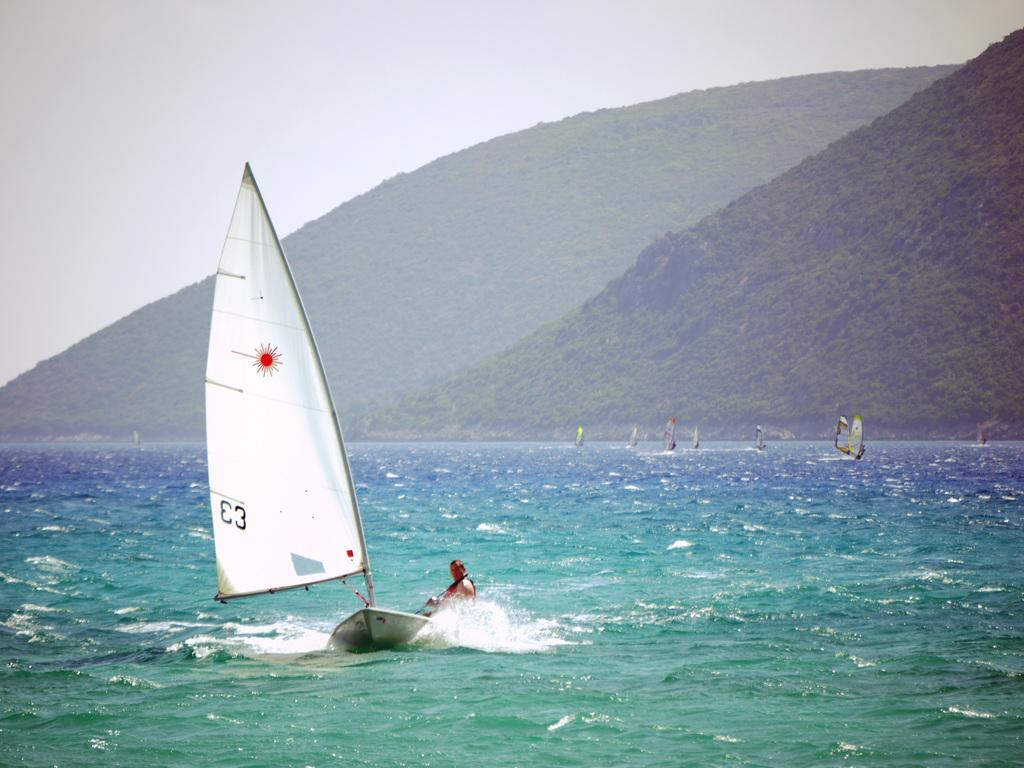What is located in the front of the image? There is water and boats in the front of the image. Can you describe the person in the image? There is a person in the front of the image. What can be seen in the background of the image? There are mountains, plants, and the sky visible in the background of the image. What type of powder is being used by the person in the image? There is no powder present in the image; it features water, boats, a person, mountains, plants, and the sky. How many pets are visible in the image? There are no pets present in the image. 